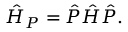<formula> <loc_0><loc_0><loc_500><loc_500>\hat { H } _ { P } = \hat { P } \hat { H } \hat { P } .</formula> 